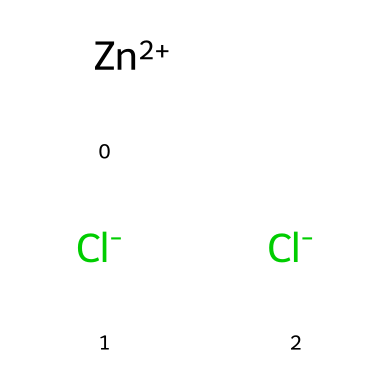What is the molecular formula of the compound? The SMILES representation indicates the presence of one zinc atom and two chlorine atoms. The molecular formula is formed by combining the symbols of these elements as per their counts.
Answer: ZnCl2 How many atoms are present in this chemical structure? The structure consists of one zinc atom and two chlorine atoms, when counting all distinct elements together. Therefore, the total number of atoms is three.
Answer: 3 What charge does the zinc ion carry in this compound? The representation includes [Zn+2], indicating that the zinc ion has a charge of +2. This charge is part of the chemical's description, as shown by the notation.
Answer: +2 What type of compound is zinc chloride classified as? Based on the presence of both metal (zinc) and non-metal (chlorine) elements, zinc chloride is classified as an ionic compound. The charge balance also confirms ionic characteristics.
Answer: ionic compound What role does zinc chloride play in the galvanizing process? Zinc chloride acts as a flux that helps to clean and prepare the surface for galvanizing, aiding adhesion and preventing oxidation. This function is key in industrial applications.
Answer: flux Why does zinc chloride dissociate into ions in solution? Zinc chloride is an electrolyte, which means it dissolves in water to produce free ions (Zn+2 and Cl- ions). This is due to its ionic nature, allowing it to ionize in solution.
Answer: to produce ions 